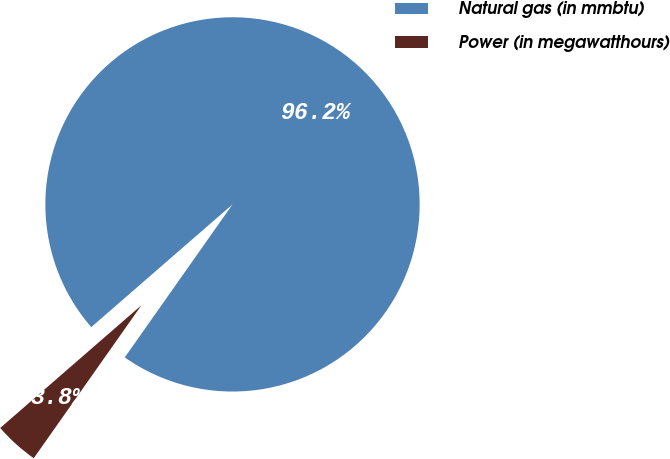<chart> <loc_0><loc_0><loc_500><loc_500><pie_chart><fcel>Natural gas (in mmbtu)<fcel>Power (in megawatthours)<nl><fcel>96.15%<fcel>3.85%<nl></chart> 